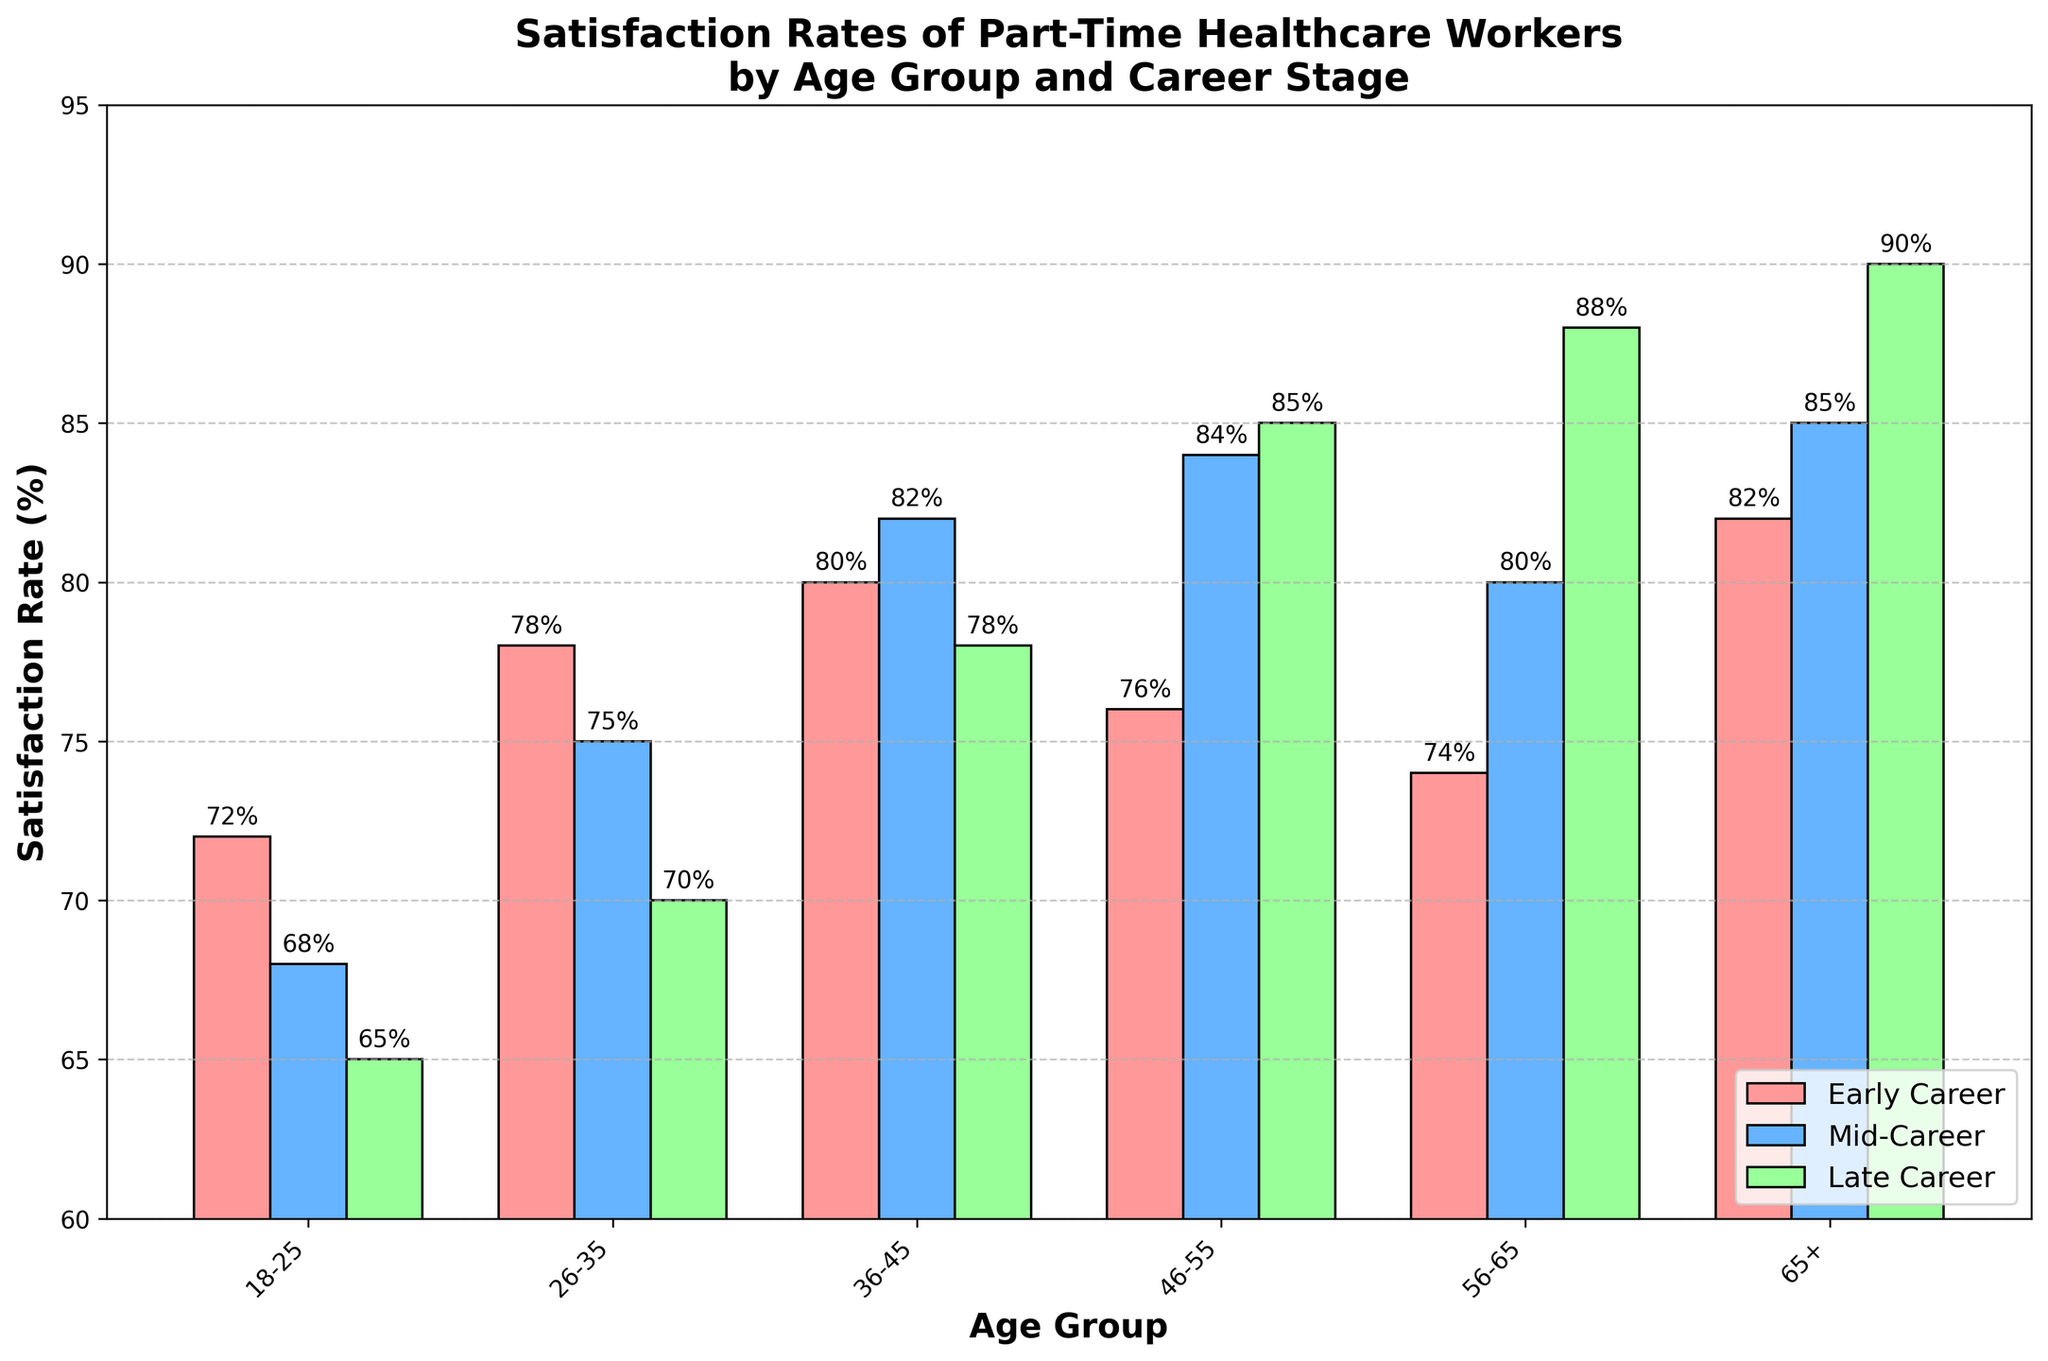What's the average satisfaction rate of mid-career part-time healthcare workers across all age groups? We take the satisfaction rates of mid-career part-time healthcare workers across all age groups (68, 75, 82, 84, 80, 85), sum them up: 68 + 75 + 82 + 84 + 80 + 85 = 474. Then we divide by the number of age groups: 474 / 6 = 79.
Answer: 79 In the age group 36-45, which career stage has the highest satisfaction rate? We look at the satisfaction rates for the age group 36-45: Early Career (80), Mid-Career (82), and Late Career (78). Mid-Career has the highest satisfaction rate of 82.
Answer: Mid-Career Which age group has the highest satisfaction rate for late career workers? We compare the satisfaction rates for late career workers across all age groups and find that the 65+ age group has the highest satisfaction rate at 90.
Answer: 65+ Compare the satisfaction rates of early career workers in the age group 18-25 and 56-65. Which age group has a higher satisfaction rate and by how much? The satisfaction rates for early career workers are 72 for 18-25 and 74 for 56-65. The 56-65 age group has a higher satisfaction rate by 74 - 72 = 2.
Answer: 56-65, by 2 For mid-career part-time healthcare workers, which age group shows the greatest increase in satisfaction rate compared to the previous age group? We examine the differences between consecutive age groups for mid-career: 26-35 (75 - 68 = 7), 36-45 (82 - 75 = 7), 46-55 (84 - 82 = 2), 56-65 (80 - 84 = -4), 65+ (85 - 80 = 5). The greatest increase occurs between the age groups 18-25 and 26-35 as well as 26-35 and 36-45, both showing an increase of 7.
Answer: 26-35 and 36-45, increase by 7 Which color represents the bars for late career satisfaction rates? By looking at the color legend in the figure, we see that the bars representing late career satisfaction rates are colored green.
Answer: Green What's the difference in satisfaction rates between early career and late career workers in the 46-55 age group? The satisfaction rates for early career and late career workers in the 46-55 age group are 76 and 85, respectively. The difference is 85 - 76 = 9.
Answer: 9 